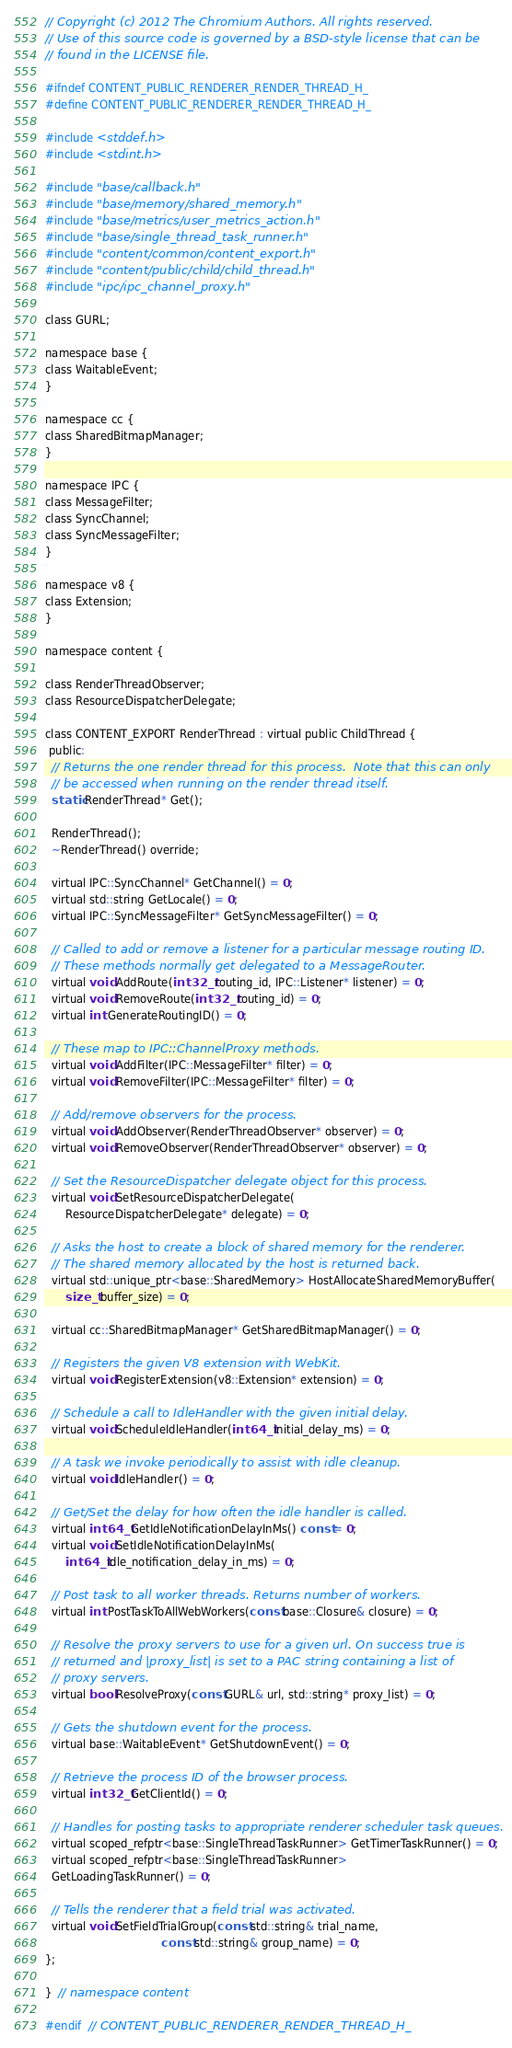Convert code to text. <code><loc_0><loc_0><loc_500><loc_500><_C_>// Copyright (c) 2012 The Chromium Authors. All rights reserved.
// Use of this source code is governed by a BSD-style license that can be
// found in the LICENSE file.

#ifndef CONTENT_PUBLIC_RENDERER_RENDER_THREAD_H_
#define CONTENT_PUBLIC_RENDERER_RENDER_THREAD_H_

#include <stddef.h>
#include <stdint.h>

#include "base/callback.h"
#include "base/memory/shared_memory.h"
#include "base/metrics/user_metrics_action.h"
#include "base/single_thread_task_runner.h"
#include "content/common/content_export.h"
#include "content/public/child/child_thread.h"
#include "ipc/ipc_channel_proxy.h"

class GURL;

namespace base {
class WaitableEvent;
}

namespace cc {
class SharedBitmapManager;
}

namespace IPC {
class MessageFilter;
class SyncChannel;
class SyncMessageFilter;
}

namespace v8 {
class Extension;
}

namespace content {

class RenderThreadObserver;
class ResourceDispatcherDelegate;

class CONTENT_EXPORT RenderThread : virtual public ChildThread {
 public:
  // Returns the one render thread for this process.  Note that this can only
  // be accessed when running on the render thread itself.
  static RenderThread* Get();

  RenderThread();
  ~RenderThread() override;

  virtual IPC::SyncChannel* GetChannel() = 0;
  virtual std::string GetLocale() = 0;
  virtual IPC::SyncMessageFilter* GetSyncMessageFilter() = 0;

  // Called to add or remove a listener for a particular message routing ID.
  // These methods normally get delegated to a MessageRouter.
  virtual void AddRoute(int32_t routing_id, IPC::Listener* listener) = 0;
  virtual void RemoveRoute(int32_t routing_id) = 0;
  virtual int GenerateRoutingID() = 0;

  // These map to IPC::ChannelProxy methods.
  virtual void AddFilter(IPC::MessageFilter* filter) = 0;
  virtual void RemoveFilter(IPC::MessageFilter* filter) = 0;

  // Add/remove observers for the process.
  virtual void AddObserver(RenderThreadObserver* observer) = 0;
  virtual void RemoveObserver(RenderThreadObserver* observer) = 0;

  // Set the ResourceDispatcher delegate object for this process.
  virtual void SetResourceDispatcherDelegate(
      ResourceDispatcherDelegate* delegate) = 0;

  // Asks the host to create a block of shared memory for the renderer.
  // The shared memory allocated by the host is returned back.
  virtual std::unique_ptr<base::SharedMemory> HostAllocateSharedMemoryBuffer(
      size_t buffer_size) = 0;

  virtual cc::SharedBitmapManager* GetSharedBitmapManager() = 0;

  // Registers the given V8 extension with WebKit.
  virtual void RegisterExtension(v8::Extension* extension) = 0;

  // Schedule a call to IdleHandler with the given initial delay.
  virtual void ScheduleIdleHandler(int64_t initial_delay_ms) = 0;

  // A task we invoke periodically to assist with idle cleanup.
  virtual void IdleHandler() = 0;

  // Get/Set the delay for how often the idle handler is called.
  virtual int64_t GetIdleNotificationDelayInMs() const = 0;
  virtual void SetIdleNotificationDelayInMs(
      int64_t idle_notification_delay_in_ms) = 0;

  // Post task to all worker threads. Returns number of workers.
  virtual int PostTaskToAllWebWorkers(const base::Closure& closure) = 0;

  // Resolve the proxy servers to use for a given url. On success true is
  // returned and |proxy_list| is set to a PAC string containing a list of
  // proxy servers.
  virtual bool ResolveProxy(const GURL& url, std::string* proxy_list) = 0;

  // Gets the shutdown event for the process.
  virtual base::WaitableEvent* GetShutdownEvent() = 0;

  // Retrieve the process ID of the browser process.
  virtual int32_t GetClientId() = 0;

  // Handles for posting tasks to appropriate renderer scheduler task queues.
  virtual scoped_refptr<base::SingleThreadTaskRunner> GetTimerTaskRunner() = 0;
  virtual scoped_refptr<base::SingleThreadTaskRunner>
  GetLoadingTaskRunner() = 0;

  // Tells the renderer that a field trial was activated.
  virtual void SetFieldTrialGroup(const std::string& trial_name,
                                  const std::string& group_name) = 0;
};

}  // namespace content

#endif  // CONTENT_PUBLIC_RENDERER_RENDER_THREAD_H_
</code> 